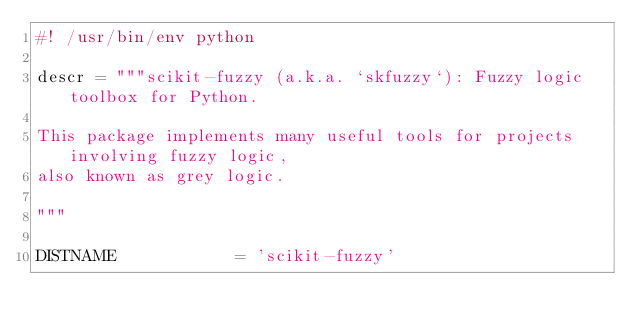<code> <loc_0><loc_0><loc_500><loc_500><_Python_>#! /usr/bin/env python

descr = """scikit-fuzzy (a.k.a. `skfuzzy`): Fuzzy logic toolbox for Python.

This package implements many useful tools for projects involving fuzzy logic,
also known as grey logic.

"""

DISTNAME            = 'scikit-fuzzy'</code> 